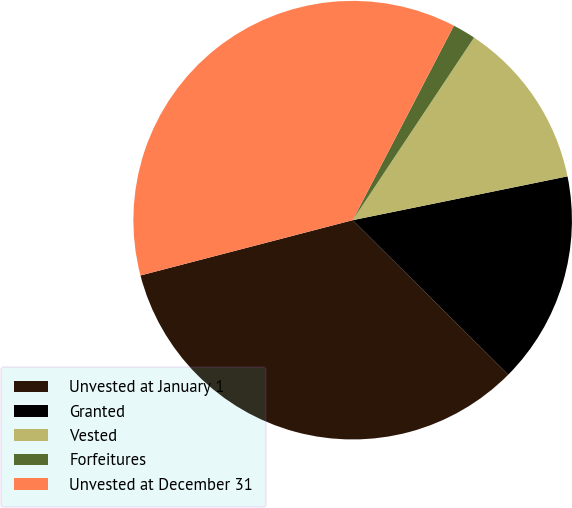Convert chart. <chart><loc_0><loc_0><loc_500><loc_500><pie_chart><fcel>Unvested at January 1<fcel>Granted<fcel>Vested<fcel>Forfeitures<fcel>Unvested at December 31<nl><fcel>33.5%<fcel>15.65%<fcel>12.46%<fcel>1.7%<fcel>36.7%<nl></chart> 